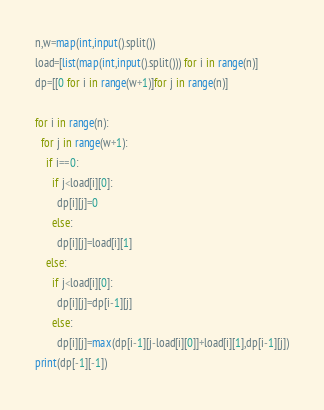<code> <loc_0><loc_0><loc_500><loc_500><_Python_>n,w=map(int,input().split())
load=[list(map(int,input().split())) for i in range(n)]
dp=[[0 for i in range(w+1)]for j in range(n)]

for i in range(n):
  for j in range(w+1):
    if i==0:
      if j<load[i][0]:
        dp[i][j]=0
      else:
        dp[i][j]=load[i][1]
    else:
      if j<load[i][0]:
        dp[i][j]=dp[i-1][j]
      else:
        dp[i][j]=max(dp[i-1][j-load[i][0]]+load[i][1],dp[i-1][j])
print(dp[-1][-1])</code> 